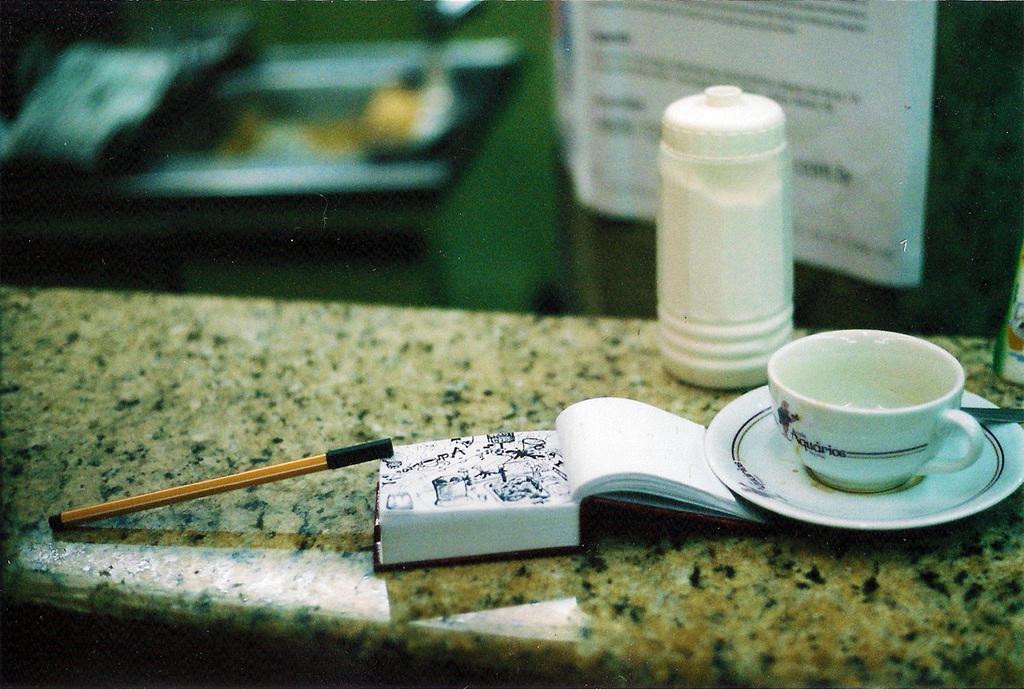Please provide a concise description of this image. In this image I can see a book, a pen, a cup and a plate. 